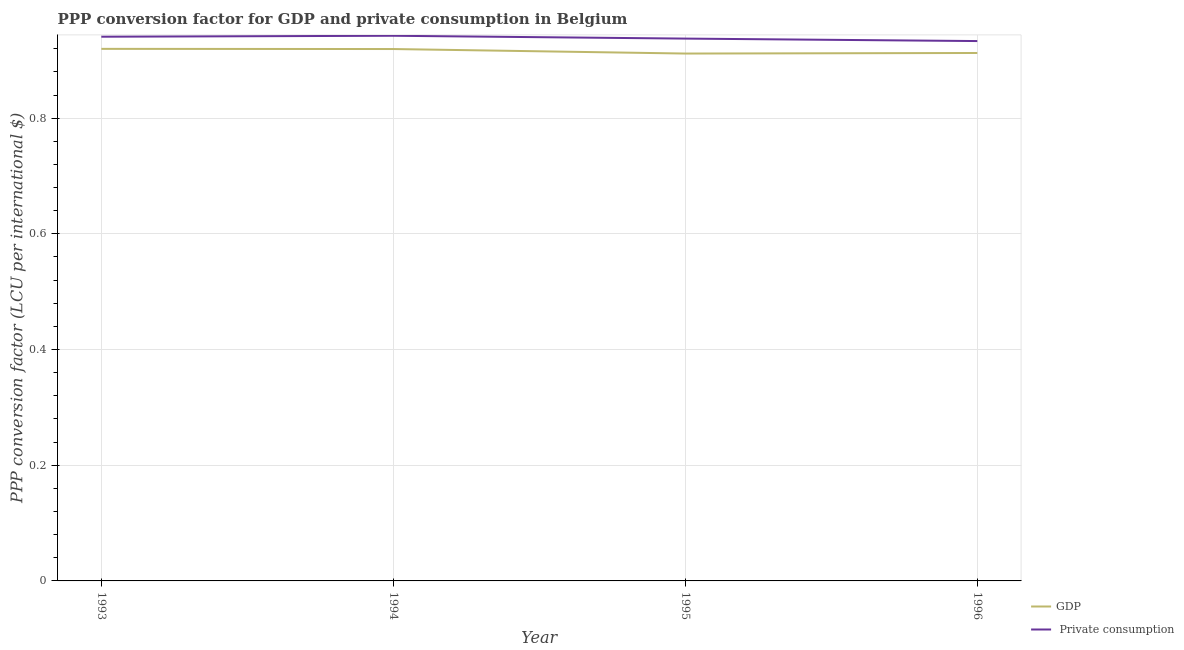How many different coloured lines are there?
Make the answer very short. 2. Is the number of lines equal to the number of legend labels?
Make the answer very short. Yes. What is the ppp conversion factor for private consumption in 1994?
Ensure brevity in your answer.  0.94. Across all years, what is the maximum ppp conversion factor for gdp?
Your answer should be compact. 0.92. Across all years, what is the minimum ppp conversion factor for private consumption?
Provide a succinct answer. 0.93. In which year was the ppp conversion factor for gdp maximum?
Your answer should be compact. 1993. In which year was the ppp conversion factor for gdp minimum?
Ensure brevity in your answer.  1995. What is the total ppp conversion factor for private consumption in the graph?
Your response must be concise. 3.75. What is the difference between the ppp conversion factor for private consumption in 1994 and that in 1995?
Offer a terse response. 0. What is the difference between the ppp conversion factor for private consumption in 1993 and the ppp conversion factor for gdp in 1995?
Offer a terse response. 0.03. What is the average ppp conversion factor for private consumption per year?
Make the answer very short. 0.94. In the year 1994, what is the difference between the ppp conversion factor for gdp and ppp conversion factor for private consumption?
Your response must be concise. -0.02. In how many years, is the ppp conversion factor for gdp greater than 0.7600000000000001 LCU?
Your answer should be compact. 4. What is the ratio of the ppp conversion factor for gdp in 1994 to that in 1995?
Provide a succinct answer. 1.01. Is the difference between the ppp conversion factor for private consumption in 1993 and 1995 greater than the difference between the ppp conversion factor for gdp in 1993 and 1995?
Ensure brevity in your answer.  No. What is the difference between the highest and the second highest ppp conversion factor for private consumption?
Ensure brevity in your answer.  0. What is the difference between the highest and the lowest ppp conversion factor for gdp?
Your answer should be very brief. 0.01. In how many years, is the ppp conversion factor for private consumption greater than the average ppp conversion factor for private consumption taken over all years?
Provide a short and direct response. 2. Is the sum of the ppp conversion factor for gdp in 1995 and 1996 greater than the maximum ppp conversion factor for private consumption across all years?
Offer a terse response. Yes. Does the ppp conversion factor for gdp monotonically increase over the years?
Make the answer very short. No. How many years are there in the graph?
Make the answer very short. 4. What is the difference between two consecutive major ticks on the Y-axis?
Make the answer very short. 0.2. Does the graph contain grids?
Your answer should be compact. Yes. Where does the legend appear in the graph?
Provide a short and direct response. Bottom right. What is the title of the graph?
Keep it short and to the point. PPP conversion factor for GDP and private consumption in Belgium. What is the label or title of the Y-axis?
Make the answer very short. PPP conversion factor (LCU per international $). What is the PPP conversion factor (LCU per international $) of GDP in 1993?
Ensure brevity in your answer.  0.92. What is the PPP conversion factor (LCU per international $) in  Private consumption in 1993?
Give a very brief answer. 0.94. What is the PPP conversion factor (LCU per international $) of GDP in 1994?
Your response must be concise. 0.92. What is the PPP conversion factor (LCU per international $) in  Private consumption in 1994?
Provide a short and direct response. 0.94. What is the PPP conversion factor (LCU per international $) in GDP in 1995?
Your answer should be compact. 0.91. What is the PPP conversion factor (LCU per international $) of  Private consumption in 1995?
Offer a very short reply. 0.94. What is the PPP conversion factor (LCU per international $) in GDP in 1996?
Offer a terse response. 0.91. What is the PPP conversion factor (LCU per international $) of  Private consumption in 1996?
Your answer should be compact. 0.93. Across all years, what is the maximum PPP conversion factor (LCU per international $) in GDP?
Make the answer very short. 0.92. Across all years, what is the maximum PPP conversion factor (LCU per international $) of  Private consumption?
Offer a terse response. 0.94. Across all years, what is the minimum PPP conversion factor (LCU per international $) in GDP?
Provide a succinct answer. 0.91. Across all years, what is the minimum PPP conversion factor (LCU per international $) of  Private consumption?
Provide a succinct answer. 0.93. What is the total PPP conversion factor (LCU per international $) in GDP in the graph?
Offer a terse response. 3.66. What is the total PPP conversion factor (LCU per international $) of  Private consumption in the graph?
Your answer should be very brief. 3.75. What is the difference between the PPP conversion factor (LCU per international $) in  Private consumption in 1993 and that in 1994?
Make the answer very short. -0. What is the difference between the PPP conversion factor (LCU per international $) of GDP in 1993 and that in 1995?
Ensure brevity in your answer.  0.01. What is the difference between the PPP conversion factor (LCU per international $) of  Private consumption in 1993 and that in 1995?
Provide a short and direct response. 0. What is the difference between the PPP conversion factor (LCU per international $) in GDP in 1993 and that in 1996?
Ensure brevity in your answer.  0.01. What is the difference between the PPP conversion factor (LCU per international $) in  Private consumption in 1993 and that in 1996?
Offer a very short reply. 0.01. What is the difference between the PPP conversion factor (LCU per international $) in GDP in 1994 and that in 1995?
Keep it short and to the point. 0.01. What is the difference between the PPP conversion factor (LCU per international $) of  Private consumption in 1994 and that in 1995?
Offer a very short reply. 0. What is the difference between the PPP conversion factor (LCU per international $) of GDP in 1994 and that in 1996?
Offer a very short reply. 0.01. What is the difference between the PPP conversion factor (LCU per international $) of  Private consumption in 1994 and that in 1996?
Your answer should be compact. 0.01. What is the difference between the PPP conversion factor (LCU per international $) in GDP in 1995 and that in 1996?
Your answer should be compact. -0. What is the difference between the PPP conversion factor (LCU per international $) of  Private consumption in 1995 and that in 1996?
Provide a short and direct response. 0. What is the difference between the PPP conversion factor (LCU per international $) in GDP in 1993 and the PPP conversion factor (LCU per international $) in  Private consumption in 1994?
Make the answer very short. -0.02. What is the difference between the PPP conversion factor (LCU per international $) of GDP in 1993 and the PPP conversion factor (LCU per international $) of  Private consumption in 1995?
Keep it short and to the point. -0.02. What is the difference between the PPP conversion factor (LCU per international $) of GDP in 1993 and the PPP conversion factor (LCU per international $) of  Private consumption in 1996?
Ensure brevity in your answer.  -0.01. What is the difference between the PPP conversion factor (LCU per international $) in GDP in 1994 and the PPP conversion factor (LCU per international $) in  Private consumption in 1995?
Offer a terse response. -0.02. What is the difference between the PPP conversion factor (LCU per international $) of GDP in 1994 and the PPP conversion factor (LCU per international $) of  Private consumption in 1996?
Make the answer very short. -0.01. What is the difference between the PPP conversion factor (LCU per international $) of GDP in 1995 and the PPP conversion factor (LCU per international $) of  Private consumption in 1996?
Ensure brevity in your answer.  -0.02. What is the average PPP conversion factor (LCU per international $) of GDP per year?
Give a very brief answer. 0.92. What is the average PPP conversion factor (LCU per international $) of  Private consumption per year?
Offer a very short reply. 0.94. In the year 1993, what is the difference between the PPP conversion factor (LCU per international $) of GDP and PPP conversion factor (LCU per international $) of  Private consumption?
Provide a short and direct response. -0.02. In the year 1994, what is the difference between the PPP conversion factor (LCU per international $) of GDP and PPP conversion factor (LCU per international $) of  Private consumption?
Your answer should be very brief. -0.02. In the year 1995, what is the difference between the PPP conversion factor (LCU per international $) in GDP and PPP conversion factor (LCU per international $) in  Private consumption?
Ensure brevity in your answer.  -0.03. In the year 1996, what is the difference between the PPP conversion factor (LCU per international $) in GDP and PPP conversion factor (LCU per international $) in  Private consumption?
Your answer should be compact. -0.02. What is the ratio of the PPP conversion factor (LCU per international $) in  Private consumption in 1993 to that in 1994?
Your answer should be compact. 1. What is the ratio of the PPP conversion factor (LCU per international $) in GDP in 1993 to that in 1995?
Your answer should be very brief. 1.01. What is the ratio of the PPP conversion factor (LCU per international $) of  Private consumption in 1993 to that in 1995?
Offer a terse response. 1. What is the ratio of the PPP conversion factor (LCU per international $) in GDP in 1993 to that in 1996?
Offer a very short reply. 1.01. What is the ratio of the PPP conversion factor (LCU per international $) in  Private consumption in 1993 to that in 1996?
Ensure brevity in your answer.  1.01. What is the ratio of the PPP conversion factor (LCU per international $) in GDP in 1994 to that in 1995?
Your answer should be compact. 1.01. What is the ratio of the PPP conversion factor (LCU per international $) of GDP in 1994 to that in 1996?
Your answer should be very brief. 1.01. What is the ratio of the PPP conversion factor (LCU per international $) of  Private consumption in 1994 to that in 1996?
Keep it short and to the point. 1.01. What is the ratio of the PPP conversion factor (LCU per international $) of GDP in 1995 to that in 1996?
Your answer should be compact. 1. What is the difference between the highest and the second highest PPP conversion factor (LCU per international $) of GDP?
Offer a terse response. 0. What is the difference between the highest and the second highest PPP conversion factor (LCU per international $) of  Private consumption?
Your answer should be compact. 0. What is the difference between the highest and the lowest PPP conversion factor (LCU per international $) in GDP?
Your answer should be very brief. 0.01. What is the difference between the highest and the lowest PPP conversion factor (LCU per international $) of  Private consumption?
Your answer should be compact. 0.01. 